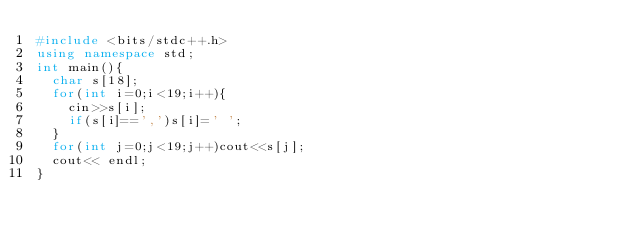<code> <loc_0><loc_0><loc_500><loc_500><_C++_>#include <bits/stdc++.h>
using namespace std;
int main(){
	char s[18];
	for(int i=0;i<19;i++){
		cin>>s[i];
		if(s[i]==',')s[i]=' ';
	}
	for(int j=0;j<19;j++)cout<<s[j];
	cout<< endl;
}
</code> 